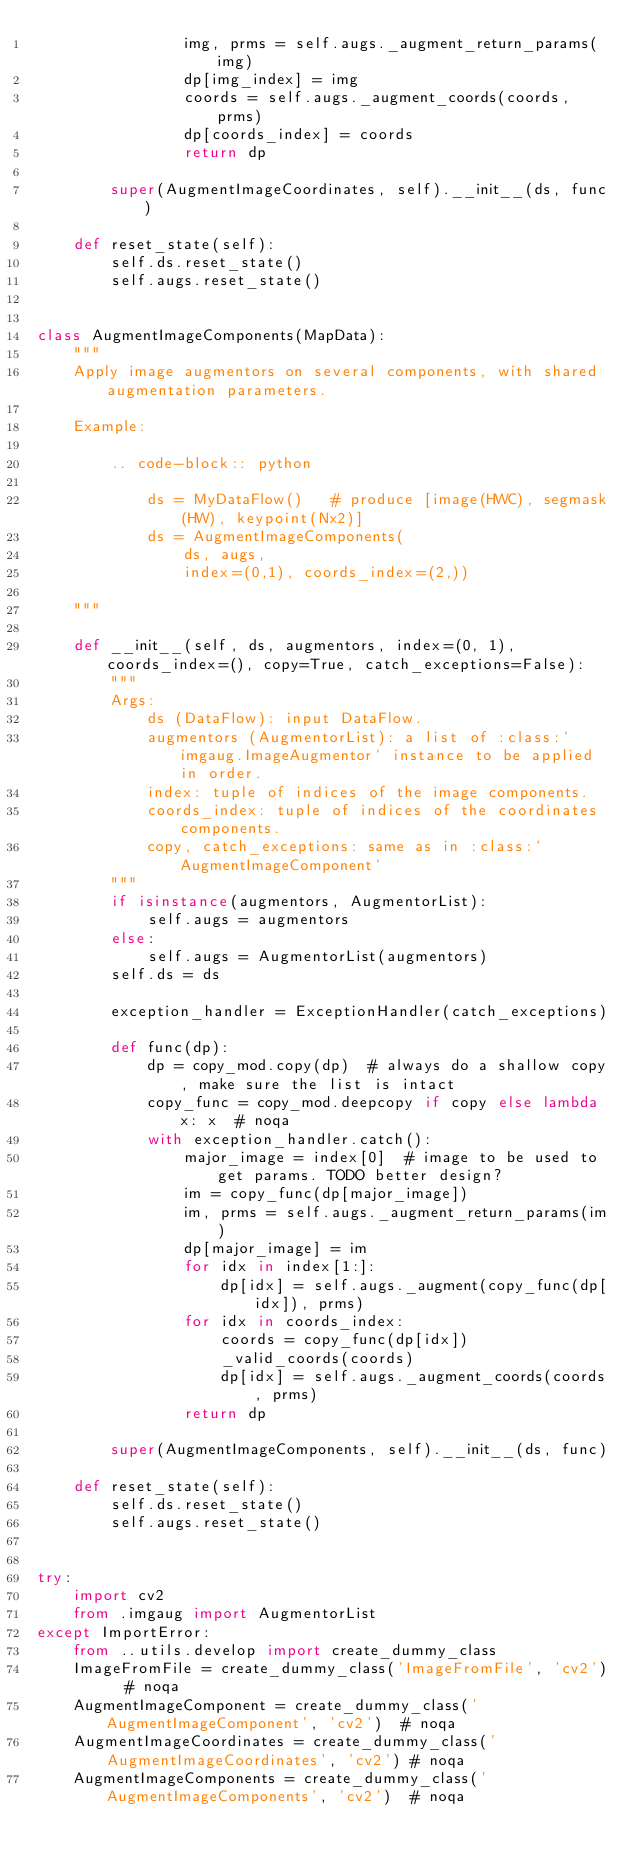Convert code to text. <code><loc_0><loc_0><loc_500><loc_500><_Python_>                img, prms = self.augs._augment_return_params(img)
                dp[img_index] = img
                coords = self.augs._augment_coords(coords, prms)
                dp[coords_index] = coords
                return dp

        super(AugmentImageCoordinates, self).__init__(ds, func)

    def reset_state(self):
        self.ds.reset_state()
        self.augs.reset_state()


class AugmentImageComponents(MapData):
    """
    Apply image augmentors on several components, with shared augmentation parameters.

    Example:

        .. code-block:: python

            ds = MyDataFlow()   # produce [image(HWC), segmask(HW), keypoint(Nx2)]
            ds = AugmentImageComponents(
                ds, augs,
                index=(0,1), coords_index=(2,))

    """

    def __init__(self, ds, augmentors, index=(0, 1), coords_index=(), copy=True, catch_exceptions=False):
        """
        Args:
            ds (DataFlow): input DataFlow.
            augmentors (AugmentorList): a list of :class:`imgaug.ImageAugmentor` instance to be applied in order.
            index: tuple of indices of the image components.
            coords_index: tuple of indices of the coordinates components.
            copy, catch_exceptions: same as in :class:`AugmentImageComponent`
        """
        if isinstance(augmentors, AugmentorList):
            self.augs = augmentors
        else:
            self.augs = AugmentorList(augmentors)
        self.ds = ds

        exception_handler = ExceptionHandler(catch_exceptions)

        def func(dp):
            dp = copy_mod.copy(dp)  # always do a shallow copy, make sure the list is intact
            copy_func = copy_mod.deepcopy if copy else lambda x: x  # noqa
            with exception_handler.catch():
                major_image = index[0]  # image to be used to get params. TODO better design?
                im = copy_func(dp[major_image])
                im, prms = self.augs._augment_return_params(im)
                dp[major_image] = im
                for idx in index[1:]:
                    dp[idx] = self.augs._augment(copy_func(dp[idx]), prms)
                for idx in coords_index:
                    coords = copy_func(dp[idx])
                    _valid_coords(coords)
                    dp[idx] = self.augs._augment_coords(coords, prms)
                return dp

        super(AugmentImageComponents, self).__init__(ds, func)

    def reset_state(self):
        self.ds.reset_state()
        self.augs.reset_state()


try:
    import cv2
    from .imgaug import AugmentorList
except ImportError:
    from ..utils.develop import create_dummy_class
    ImageFromFile = create_dummy_class('ImageFromFile', 'cv2')  # noqa
    AugmentImageComponent = create_dummy_class('AugmentImageComponent', 'cv2')  # noqa
    AugmentImageCoordinates = create_dummy_class('AugmentImageCoordinates', 'cv2') # noqa
    AugmentImageComponents = create_dummy_class('AugmentImageComponents', 'cv2')  # noqa
</code> 